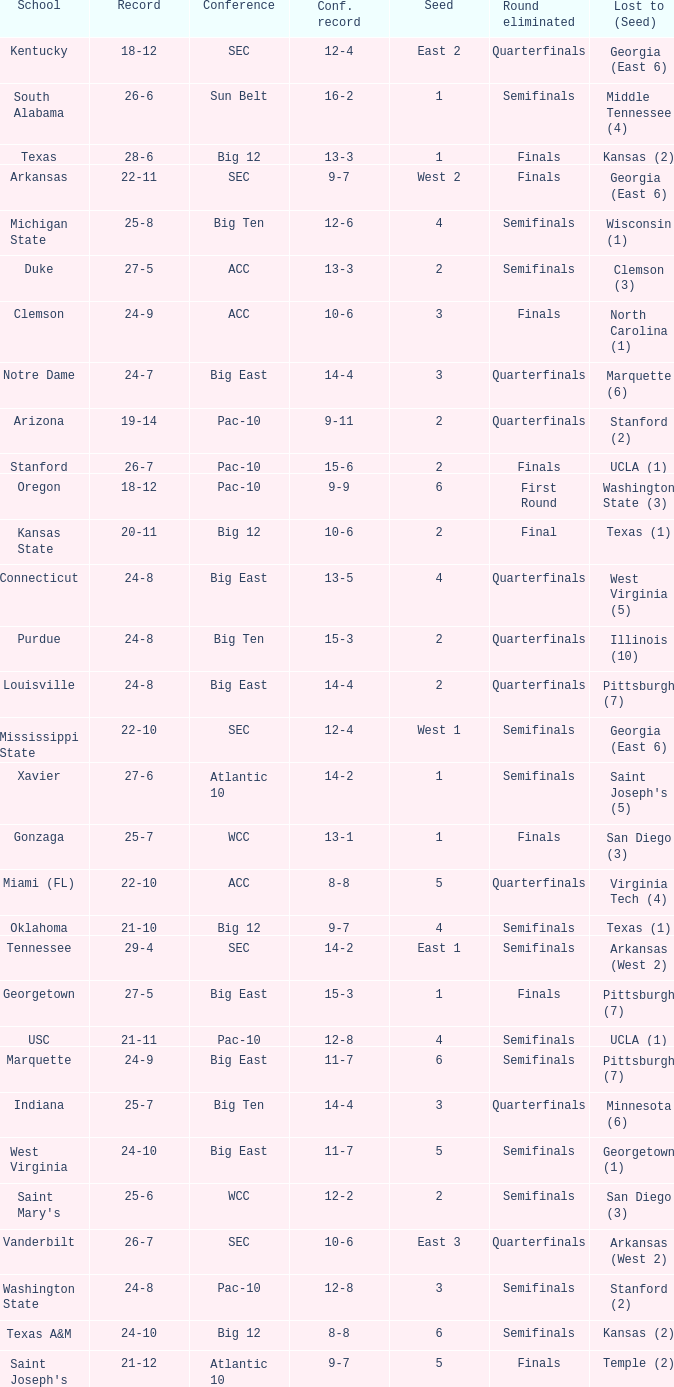Can you give me this table as a dict? {'header': ['School', 'Record', 'Conference', 'Conf. record', 'Seed', 'Round eliminated', 'Lost to (Seed)'], 'rows': [['Kentucky', '18-12', 'SEC', '12-4', 'East 2', 'Quarterfinals', 'Georgia (East 6)'], ['South Alabama', '26-6', 'Sun Belt', '16-2', '1', 'Semifinals', 'Middle Tennessee (4)'], ['Texas', '28-6', 'Big 12', '13-3', '1', 'Finals', 'Kansas (2)'], ['Arkansas', '22-11', 'SEC', '9-7', 'West 2', 'Finals', 'Georgia (East 6)'], ['Michigan State', '25-8', 'Big Ten', '12-6', '4', 'Semifinals', 'Wisconsin (1)'], ['Duke', '27-5', 'ACC', '13-3', '2', 'Semifinals', 'Clemson (3)'], ['Clemson', '24-9', 'ACC', '10-6', '3', 'Finals', 'North Carolina (1)'], ['Notre Dame', '24-7', 'Big East', '14-4', '3', 'Quarterfinals', 'Marquette (6)'], ['Arizona', '19-14', 'Pac-10', '9-11', '2', 'Quarterfinals', 'Stanford (2)'], ['Stanford', '26-7', 'Pac-10', '15-6', '2', 'Finals', 'UCLA (1)'], ['Oregon', '18-12', 'Pac-10', '9-9', '6', 'First Round', 'Washington State (3)'], ['Kansas State', '20-11', 'Big 12', '10-6', '2', 'Final', 'Texas (1)'], ['Connecticut', '24-8', 'Big East', '13-5', '4', 'Quarterfinals', 'West Virginia (5)'], ['Purdue', '24-8', 'Big Ten', '15-3', '2', 'Quarterfinals', 'Illinois (10)'], ['Louisville', '24-8', 'Big East', '14-4', '2', 'Quarterfinals', 'Pittsburgh (7)'], ['Mississippi State', '22-10', 'SEC', '12-4', 'West 1', 'Semifinals', 'Georgia (East 6)'], ['Xavier', '27-6', 'Atlantic 10', '14-2', '1', 'Semifinals', "Saint Joseph's (5)"], ['Gonzaga', '25-7', 'WCC', '13-1', '1', 'Finals', 'San Diego (3)'], ['Miami (FL)', '22-10', 'ACC', '8-8', '5', 'Quarterfinals', 'Virginia Tech (4)'], ['Oklahoma', '21-10', 'Big 12', '9-7', '4', 'Semifinals', 'Texas (1)'], ['Tennessee', '29-4', 'SEC', '14-2', 'East 1', 'Semifinals', 'Arkansas (West 2)'], ['Georgetown', '27-5', 'Big East', '15-3', '1', 'Finals', 'Pittsburgh (7)'], ['USC', '21-11', 'Pac-10', '12-8', '4', 'Semifinals', 'UCLA (1)'], ['Marquette', '24-9', 'Big East', '11-7', '6', 'Semifinals', 'Pittsburgh (7)'], ['Indiana', '25-7', 'Big Ten', '14-4', '3', 'Quarterfinals', 'Minnesota (6)'], ['West Virginia', '24-10', 'Big East', '11-7', '5', 'Semifinals', 'Georgetown (1)'], ["Saint Mary's", '25-6', 'WCC', '12-2', '2', 'Semifinals', 'San Diego (3)'], ['Vanderbilt', '26-7', 'SEC', '10-6', 'East 3', 'Quarterfinals', 'Arkansas (West 2)'], ['Washington State', '24-8', 'Pac-10', '12-8', '3', 'Semifinals', 'Stanford (2)'], ['Texas A&M', '24-10', 'Big 12', '8-8', '6', 'Semifinals', 'Kansas (2)'], ["Saint Joseph's", '21-12', 'Atlantic 10', '9-7', '5', 'Finals', 'Temple (2)'], ['Baylor', '21-10', 'Big 12', '9-7', '5', 'First Round', 'Colorado (12)'], ['Brigham Young', '27-7', 'Mountain West', '16-3', '1', 'Finals', 'UNLV (2)']]} Name the school where conference record is 12-6 Michigan State. 